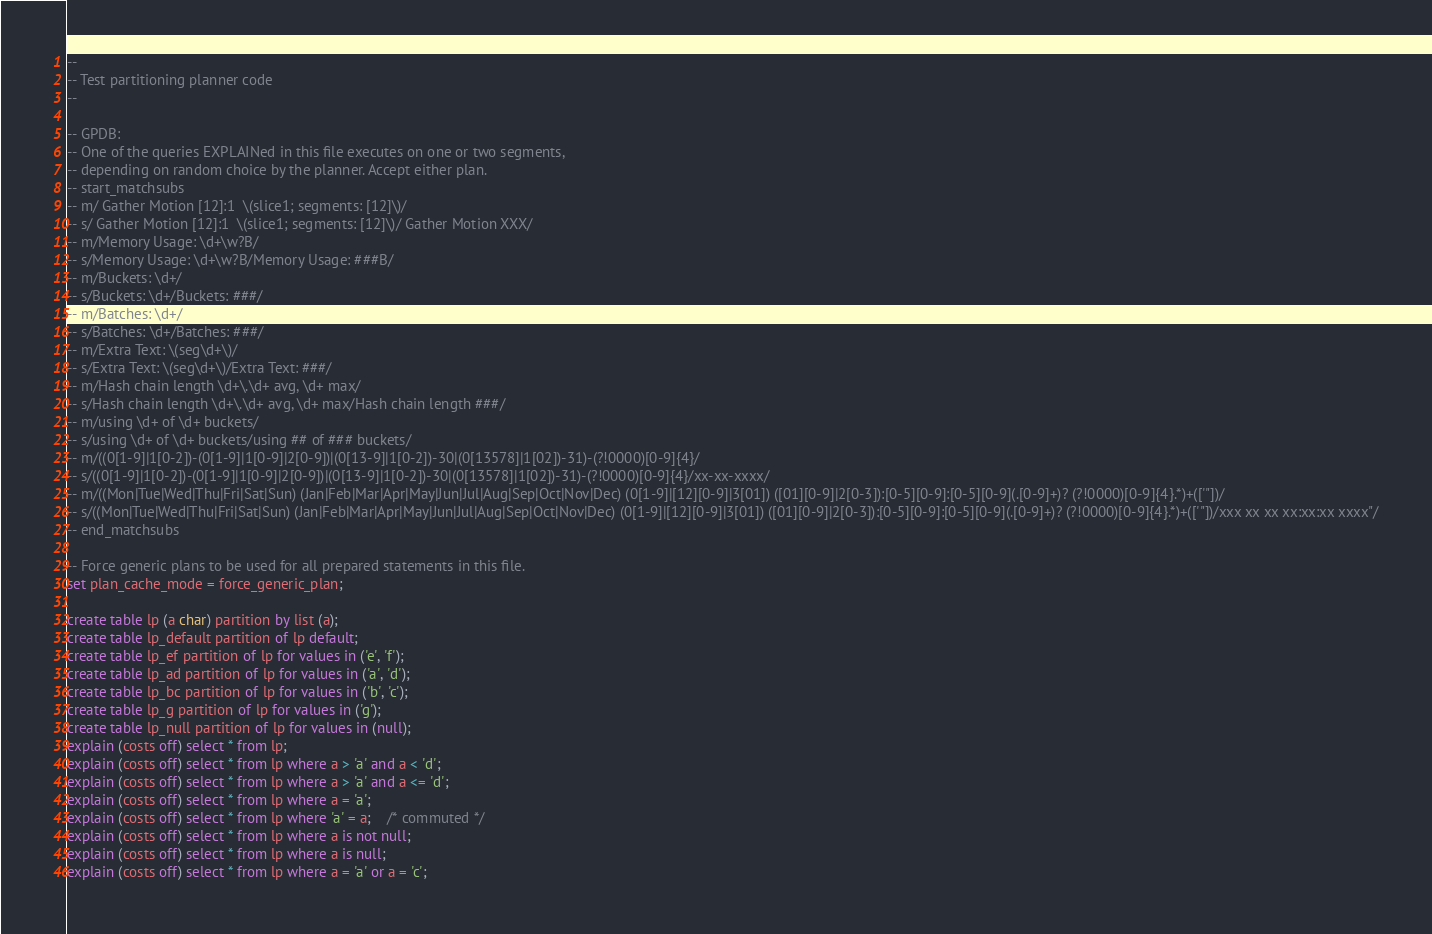Convert code to text. <code><loc_0><loc_0><loc_500><loc_500><_SQL_>--
-- Test partitioning planner code
--

-- GPDB:
-- One of the queries EXPLAINed in this file executes on one or two segments,
-- depending on random choice by the planner. Accept either plan.
-- start_matchsubs
-- m/ Gather Motion [12]:1  \(slice1; segments: [12]\)/
-- s/ Gather Motion [12]:1  \(slice1; segments: [12]\)/ Gather Motion XXX/
-- m/Memory Usage: \d+\w?B/
-- s/Memory Usage: \d+\w?B/Memory Usage: ###B/
-- m/Buckets: \d+/
-- s/Buckets: \d+/Buckets: ###/
-- m/Batches: \d+/
-- s/Batches: \d+/Batches: ###/
-- m/Extra Text: \(seg\d+\)/
-- s/Extra Text: \(seg\d+\)/Extra Text: ###/
-- m/Hash chain length \d+\.\d+ avg, \d+ max/
-- s/Hash chain length \d+\.\d+ avg, \d+ max/Hash chain length ###/
-- m/using \d+ of \d+ buckets/
-- s/using \d+ of \d+ buckets/using ## of ### buckets/
-- m/((0[1-9]|1[0-2])-(0[1-9]|1[0-9]|2[0-9])|(0[13-9]|1[0-2])-30|(0[13578]|1[02])-31)-(?!0000)[0-9]{4}/
-- s/((0[1-9]|1[0-2])-(0[1-9]|1[0-9]|2[0-9])|(0[13-9]|1[0-2])-30|(0[13578]|1[02])-31)-(?!0000)[0-9]{4}/xx-xx-xxxx/
-- m/((Mon|Tue|Wed|Thu|Fri|Sat|Sun) (Jan|Feb|Mar|Apr|May|Jun|Jul|Aug|Sep|Oct|Nov|Dec) (0[1-9]|[12][0-9]|3[01]) ([01][0-9]|2[0-3]):[0-5][0-9]:[0-5][0-9](.[0-9]+)? (?!0000)[0-9]{4}.*)+(['"])/
-- s/((Mon|Tue|Wed|Thu|Fri|Sat|Sun) (Jan|Feb|Mar|Apr|May|Jun|Jul|Aug|Sep|Oct|Nov|Dec) (0[1-9]|[12][0-9]|3[01]) ([01][0-9]|2[0-3]):[0-5][0-9]:[0-5][0-9](.[0-9]+)? (?!0000)[0-9]{4}.*)+(['"])/xxx xx xx xx:xx:xx xxxx"/
-- end_matchsubs

-- Force generic plans to be used for all prepared statements in this file.
set plan_cache_mode = force_generic_plan;

create table lp (a char) partition by list (a);
create table lp_default partition of lp default;
create table lp_ef partition of lp for values in ('e', 'f');
create table lp_ad partition of lp for values in ('a', 'd');
create table lp_bc partition of lp for values in ('b', 'c');
create table lp_g partition of lp for values in ('g');
create table lp_null partition of lp for values in (null);
explain (costs off) select * from lp;
explain (costs off) select * from lp where a > 'a' and a < 'd';
explain (costs off) select * from lp where a > 'a' and a <= 'd';
explain (costs off) select * from lp where a = 'a';
explain (costs off) select * from lp where 'a' = a;	/* commuted */
explain (costs off) select * from lp where a is not null;
explain (costs off) select * from lp where a is null;
explain (costs off) select * from lp where a = 'a' or a = 'c';</code> 